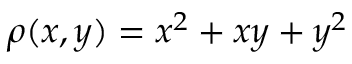Convert formula to latex. <formula><loc_0><loc_0><loc_500><loc_500>\rho ( x , y ) = x ^ { 2 } + x y + y ^ { 2 }</formula> 